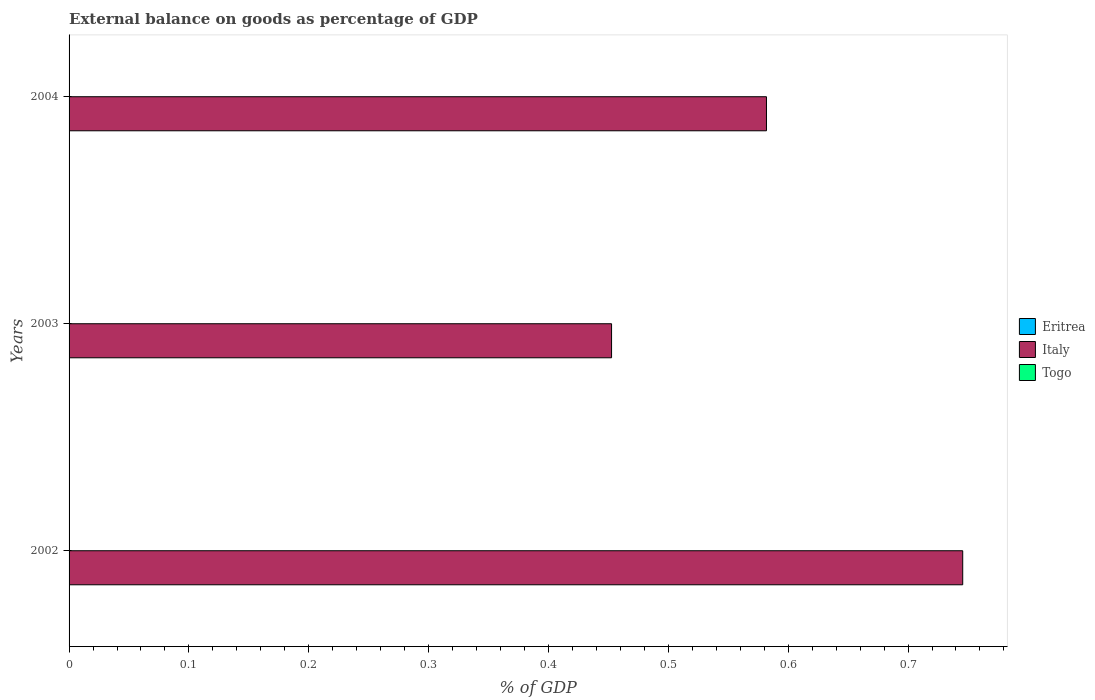Are the number of bars per tick equal to the number of legend labels?
Keep it short and to the point. No. Are the number of bars on each tick of the Y-axis equal?
Provide a succinct answer. Yes. How many bars are there on the 2nd tick from the bottom?
Provide a succinct answer. 1. What is the label of the 1st group of bars from the top?
Give a very brief answer. 2004. Across all years, what is the maximum external balance on goods as percentage of GDP in Italy?
Offer a very short reply. 0.75. Across all years, what is the minimum external balance on goods as percentage of GDP in Eritrea?
Ensure brevity in your answer.  0. What is the total external balance on goods as percentage of GDP in Italy in the graph?
Provide a succinct answer. 1.78. What is the difference between the external balance on goods as percentage of GDP in Italy in 2003 and that in 2004?
Your answer should be compact. -0.13. What is the difference between the external balance on goods as percentage of GDP in Italy in 2003 and the external balance on goods as percentage of GDP in Eritrea in 2002?
Ensure brevity in your answer.  0.45. What is the average external balance on goods as percentage of GDP in Italy per year?
Provide a succinct answer. 0.59. What is the ratio of the external balance on goods as percentage of GDP in Italy in 2003 to that in 2004?
Your response must be concise. 0.78. What is the difference between the highest and the second highest external balance on goods as percentage of GDP in Italy?
Make the answer very short. 0.16. What is the difference between the highest and the lowest external balance on goods as percentage of GDP in Italy?
Give a very brief answer. 0.29. In how many years, is the external balance on goods as percentage of GDP in Eritrea greater than the average external balance on goods as percentage of GDP in Eritrea taken over all years?
Provide a short and direct response. 0. Is the sum of the external balance on goods as percentage of GDP in Italy in 2002 and 2004 greater than the maximum external balance on goods as percentage of GDP in Togo across all years?
Your answer should be very brief. Yes. Is it the case that in every year, the sum of the external balance on goods as percentage of GDP in Eritrea and external balance on goods as percentage of GDP in Togo is greater than the external balance on goods as percentage of GDP in Italy?
Your answer should be compact. No. How many bars are there?
Keep it short and to the point. 3. Are all the bars in the graph horizontal?
Offer a very short reply. Yes. What is the difference between two consecutive major ticks on the X-axis?
Give a very brief answer. 0.1. Are the values on the major ticks of X-axis written in scientific E-notation?
Your answer should be compact. No. Where does the legend appear in the graph?
Make the answer very short. Center right. How many legend labels are there?
Offer a very short reply. 3. How are the legend labels stacked?
Keep it short and to the point. Vertical. What is the title of the graph?
Your response must be concise. External balance on goods as percentage of GDP. What is the label or title of the X-axis?
Give a very brief answer. % of GDP. What is the % of GDP of Italy in 2002?
Provide a short and direct response. 0.75. What is the % of GDP in Togo in 2002?
Your answer should be compact. 0. What is the % of GDP in Eritrea in 2003?
Your response must be concise. 0. What is the % of GDP in Italy in 2003?
Offer a terse response. 0.45. What is the % of GDP of Italy in 2004?
Your answer should be very brief. 0.58. What is the % of GDP of Togo in 2004?
Provide a succinct answer. 0. Across all years, what is the maximum % of GDP of Italy?
Offer a terse response. 0.75. Across all years, what is the minimum % of GDP of Italy?
Provide a short and direct response. 0.45. What is the total % of GDP in Eritrea in the graph?
Your answer should be compact. 0. What is the total % of GDP in Italy in the graph?
Provide a short and direct response. 1.78. What is the total % of GDP of Togo in the graph?
Your response must be concise. 0. What is the difference between the % of GDP of Italy in 2002 and that in 2003?
Make the answer very short. 0.29. What is the difference between the % of GDP in Italy in 2002 and that in 2004?
Provide a short and direct response. 0.16. What is the difference between the % of GDP of Italy in 2003 and that in 2004?
Provide a short and direct response. -0.13. What is the average % of GDP of Eritrea per year?
Your answer should be very brief. 0. What is the average % of GDP of Italy per year?
Make the answer very short. 0.59. What is the average % of GDP of Togo per year?
Give a very brief answer. 0. What is the ratio of the % of GDP of Italy in 2002 to that in 2003?
Ensure brevity in your answer.  1.65. What is the ratio of the % of GDP of Italy in 2002 to that in 2004?
Offer a terse response. 1.28. What is the ratio of the % of GDP of Italy in 2003 to that in 2004?
Provide a short and direct response. 0.78. What is the difference between the highest and the second highest % of GDP of Italy?
Offer a very short reply. 0.16. What is the difference between the highest and the lowest % of GDP of Italy?
Offer a terse response. 0.29. 